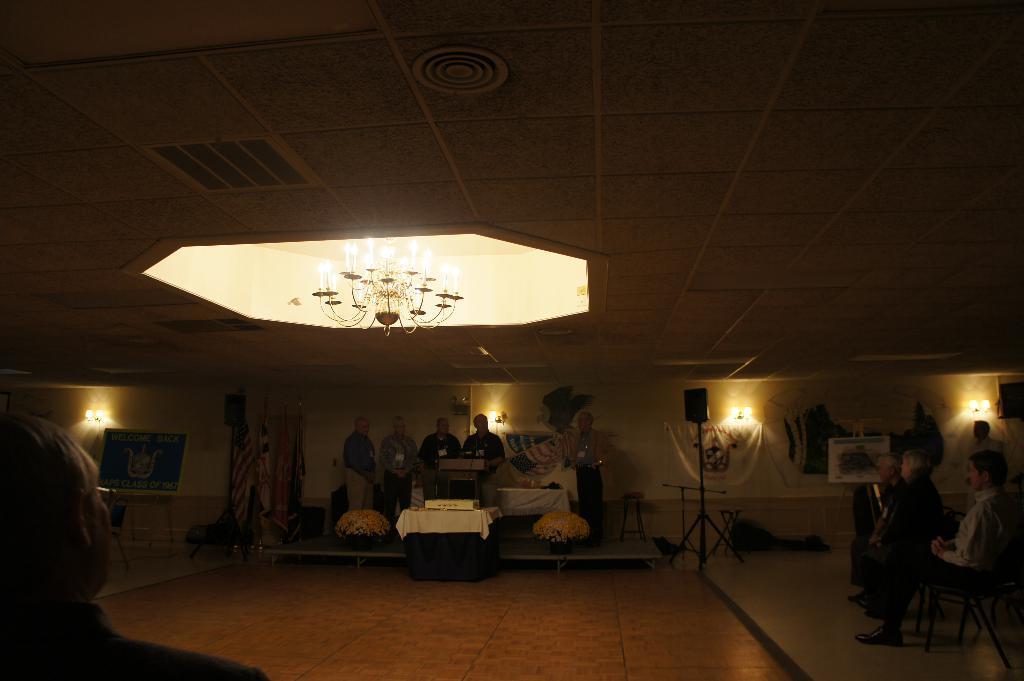How would you summarize this image in a sentence or two? In the middle of the picture, we see people are standing. In front of them, we see a table. Behind them, we see a wall. On the right side, we see people are sitting on the chairs. In the background, we see a white wall, speaker box and lights. At the top of the picture, we see a chandelier. This picture is clicked in the dark. 